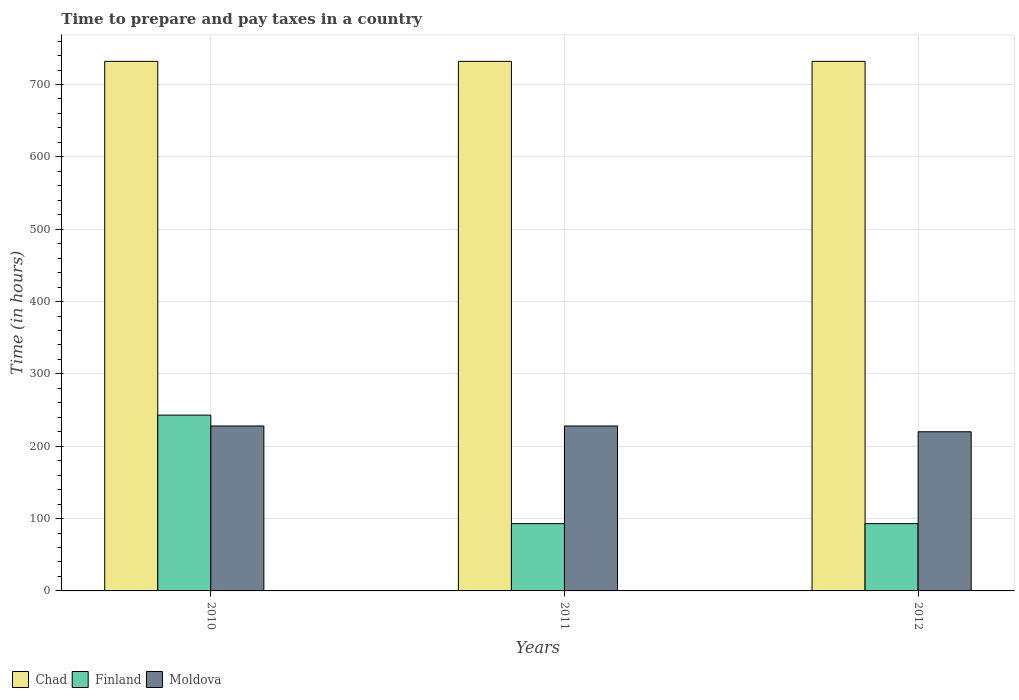How many groups of bars are there?
Your answer should be compact. 3. Are the number of bars per tick equal to the number of legend labels?
Your response must be concise. Yes. How many bars are there on the 3rd tick from the right?
Make the answer very short. 3. In how many cases, is the number of bars for a given year not equal to the number of legend labels?
Offer a very short reply. 0. What is the number of hours required to prepare and pay taxes in Finland in 2012?
Offer a terse response. 93. Across all years, what is the maximum number of hours required to prepare and pay taxes in Finland?
Keep it short and to the point. 243. Across all years, what is the minimum number of hours required to prepare and pay taxes in Chad?
Your answer should be very brief. 732. In which year was the number of hours required to prepare and pay taxes in Finland maximum?
Ensure brevity in your answer.  2010. In which year was the number of hours required to prepare and pay taxes in Finland minimum?
Offer a terse response. 2011. What is the total number of hours required to prepare and pay taxes in Chad in the graph?
Offer a very short reply. 2196. What is the difference between the number of hours required to prepare and pay taxes in Moldova in 2011 and the number of hours required to prepare and pay taxes in Finland in 2012?
Your answer should be compact. 135. What is the average number of hours required to prepare and pay taxes in Chad per year?
Your response must be concise. 732. In the year 2012, what is the difference between the number of hours required to prepare and pay taxes in Moldova and number of hours required to prepare and pay taxes in Finland?
Offer a very short reply. 127. In how many years, is the number of hours required to prepare and pay taxes in Moldova greater than 600 hours?
Your answer should be very brief. 0. What is the ratio of the number of hours required to prepare and pay taxes in Moldova in 2010 to that in 2012?
Offer a terse response. 1.04. Is the number of hours required to prepare and pay taxes in Finland in 2010 less than that in 2012?
Keep it short and to the point. No. Is the difference between the number of hours required to prepare and pay taxes in Moldova in 2010 and 2012 greater than the difference between the number of hours required to prepare and pay taxes in Finland in 2010 and 2012?
Offer a terse response. No. What is the difference between the highest and the lowest number of hours required to prepare and pay taxes in Chad?
Give a very brief answer. 0. Is the sum of the number of hours required to prepare and pay taxes in Finland in 2011 and 2012 greater than the maximum number of hours required to prepare and pay taxes in Chad across all years?
Your answer should be very brief. No. What does the 2nd bar from the left in 2010 represents?
Offer a very short reply. Finland. What does the 1st bar from the right in 2011 represents?
Offer a terse response. Moldova. Is it the case that in every year, the sum of the number of hours required to prepare and pay taxes in Moldova and number of hours required to prepare and pay taxes in Finland is greater than the number of hours required to prepare and pay taxes in Chad?
Provide a succinct answer. No. How many bars are there?
Ensure brevity in your answer.  9. Are all the bars in the graph horizontal?
Keep it short and to the point. No. What is the title of the graph?
Give a very brief answer. Time to prepare and pay taxes in a country. Does "Austria" appear as one of the legend labels in the graph?
Your response must be concise. No. What is the label or title of the Y-axis?
Offer a very short reply. Time (in hours). What is the Time (in hours) of Chad in 2010?
Offer a very short reply. 732. What is the Time (in hours) in Finland in 2010?
Give a very brief answer. 243. What is the Time (in hours) of Moldova in 2010?
Ensure brevity in your answer.  228. What is the Time (in hours) of Chad in 2011?
Offer a very short reply. 732. What is the Time (in hours) in Finland in 2011?
Provide a succinct answer. 93. What is the Time (in hours) in Moldova in 2011?
Offer a terse response. 228. What is the Time (in hours) in Chad in 2012?
Your answer should be very brief. 732. What is the Time (in hours) in Finland in 2012?
Provide a short and direct response. 93. What is the Time (in hours) of Moldova in 2012?
Offer a terse response. 220. Across all years, what is the maximum Time (in hours) of Chad?
Provide a short and direct response. 732. Across all years, what is the maximum Time (in hours) of Finland?
Offer a very short reply. 243. Across all years, what is the maximum Time (in hours) of Moldova?
Keep it short and to the point. 228. Across all years, what is the minimum Time (in hours) of Chad?
Your answer should be very brief. 732. Across all years, what is the minimum Time (in hours) of Finland?
Your answer should be compact. 93. Across all years, what is the minimum Time (in hours) of Moldova?
Ensure brevity in your answer.  220. What is the total Time (in hours) in Chad in the graph?
Make the answer very short. 2196. What is the total Time (in hours) of Finland in the graph?
Your response must be concise. 429. What is the total Time (in hours) of Moldova in the graph?
Provide a short and direct response. 676. What is the difference between the Time (in hours) in Finland in 2010 and that in 2011?
Keep it short and to the point. 150. What is the difference between the Time (in hours) in Moldova in 2010 and that in 2011?
Provide a succinct answer. 0. What is the difference between the Time (in hours) of Finland in 2010 and that in 2012?
Your answer should be very brief. 150. What is the difference between the Time (in hours) of Moldova in 2010 and that in 2012?
Keep it short and to the point. 8. What is the difference between the Time (in hours) in Moldova in 2011 and that in 2012?
Offer a terse response. 8. What is the difference between the Time (in hours) in Chad in 2010 and the Time (in hours) in Finland in 2011?
Give a very brief answer. 639. What is the difference between the Time (in hours) of Chad in 2010 and the Time (in hours) of Moldova in 2011?
Ensure brevity in your answer.  504. What is the difference between the Time (in hours) of Chad in 2010 and the Time (in hours) of Finland in 2012?
Make the answer very short. 639. What is the difference between the Time (in hours) of Chad in 2010 and the Time (in hours) of Moldova in 2012?
Make the answer very short. 512. What is the difference between the Time (in hours) in Chad in 2011 and the Time (in hours) in Finland in 2012?
Offer a terse response. 639. What is the difference between the Time (in hours) of Chad in 2011 and the Time (in hours) of Moldova in 2012?
Your response must be concise. 512. What is the difference between the Time (in hours) of Finland in 2011 and the Time (in hours) of Moldova in 2012?
Keep it short and to the point. -127. What is the average Time (in hours) in Chad per year?
Your response must be concise. 732. What is the average Time (in hours) in Finland per year?
Make the answer very short. 143. What is the average Time (in hours) in Moldova per year?
Provide a short and direct response. 225.33. In the year 2010, what is the difference between the Time (in hours) of Chad and Time (in hours) of Finland?
Make the answer very short. 489. In the year 2010, what is the difference between the Time (in hours) of Chad and Time (in hours) of Moldova?
Provide a succinct answer. 504. In the year 2011, what is the difference between the Time (in hours) of Chad and Time (in hours) of Finland?
Provide a short and direct response. 639. In the year 2011, what is the difference between the Time (in hours) in Chad and Time (in hours) in Moldova?
Give a very brief answer. 504. In the year 2011, what is the difference between the Time (in hours) in Finland and Time (in hours) in Moldova?
Ensure brevity in your answer.  -135. In the year 2012, what is the difference between the Time (in hours) in Chad and Time (in hours) in Finland?
Your answer should be very brief. 639. In the year 2012, what is the difference between the Time (in hours) in Chad and Time (in hours) in Moldova?
Offer a very short reply. 512. In the year 2012, what is the difference between the Time (in hours) in Finland and Time (in hours) in Moldova?
Provide a succinct answer. -127. What is the ratio of the Time (in hours) in Chad in 2010 to that in 2011?
Ensure brevity in your answer.  1. What is the ratio of the Time (in hours) of Finland in 2010 to that in 2011?
Offer a terse response. 2.61. What is the ratio of the Time (in hours) of Moldova in 2010 to that in 2011?
Your answer should be very brief. 1. What is the ratio of the Time (in hours) in Chad in 2010 to that in 2012?
Your answer should be very brief. 1. What is the ratio of the Time (in hours) of Finland in 2010 to that in 2012?
Provide a succinct answer. 2.61. What is the ratio of the Time (in hours) in Moldova in 2010 to that in 2012?
Keep it short and to the point. 1.04. What is the ratio of the Time (in hours) in Finland in 2011 to that in 2012?
Your answer should be very brief. 1. What is the ratio of the Time (in hours) in Moldova in 2011 to that in 2012?
Your response must be concise. 1.04. What is the difference between the highest and the second highest Time (in hours) in Chad?
Your answer should be very brief. 0. What is the difference between the highest and the second highest Time (in hours) in Finland?
Give a very brief answer. 150. What is the difference between the highest and the lowest Time (in hours) of Finland?
Your response must be concise. 150. What is the difference between the highest and the lowest Time (in hours) in Moldova?
Provide a short and direct response. 8. 